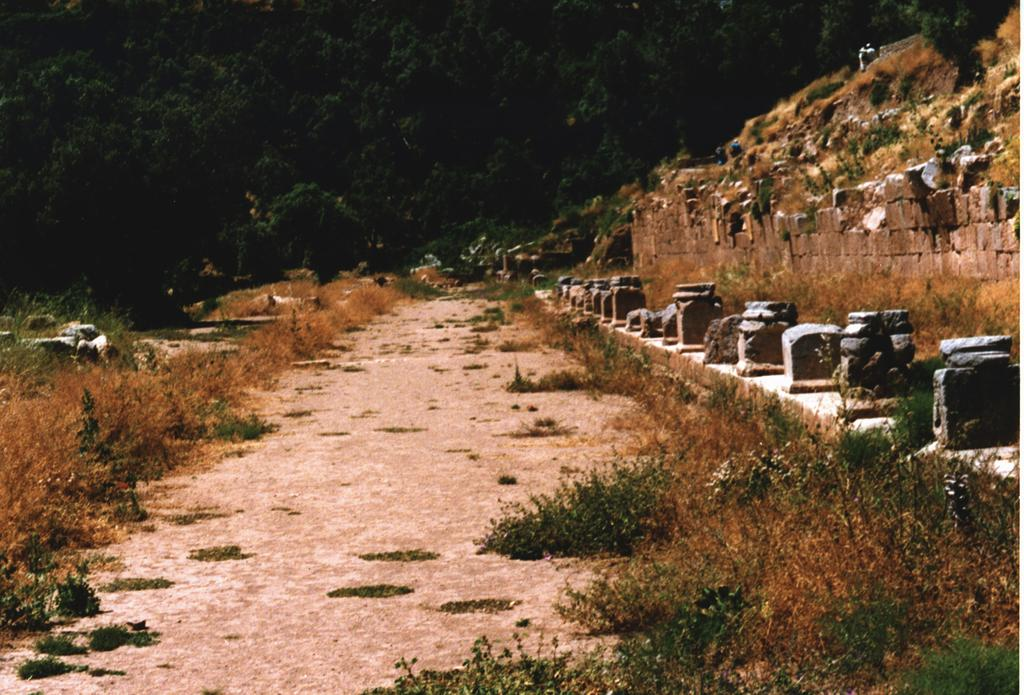What type of vegetation is on the ground in the image? There are plants on the ground in the image. What can be seen on the right side of the image? There are stones on the right side of the image. What is visible in the background of the image? There are trees and a hill visible in the background of the image. What word is written on the hill in the image? There is no word written on the hill in the image; it is a natural landscape feature. Can you see any sails in the image? There are no sails present in the image. 